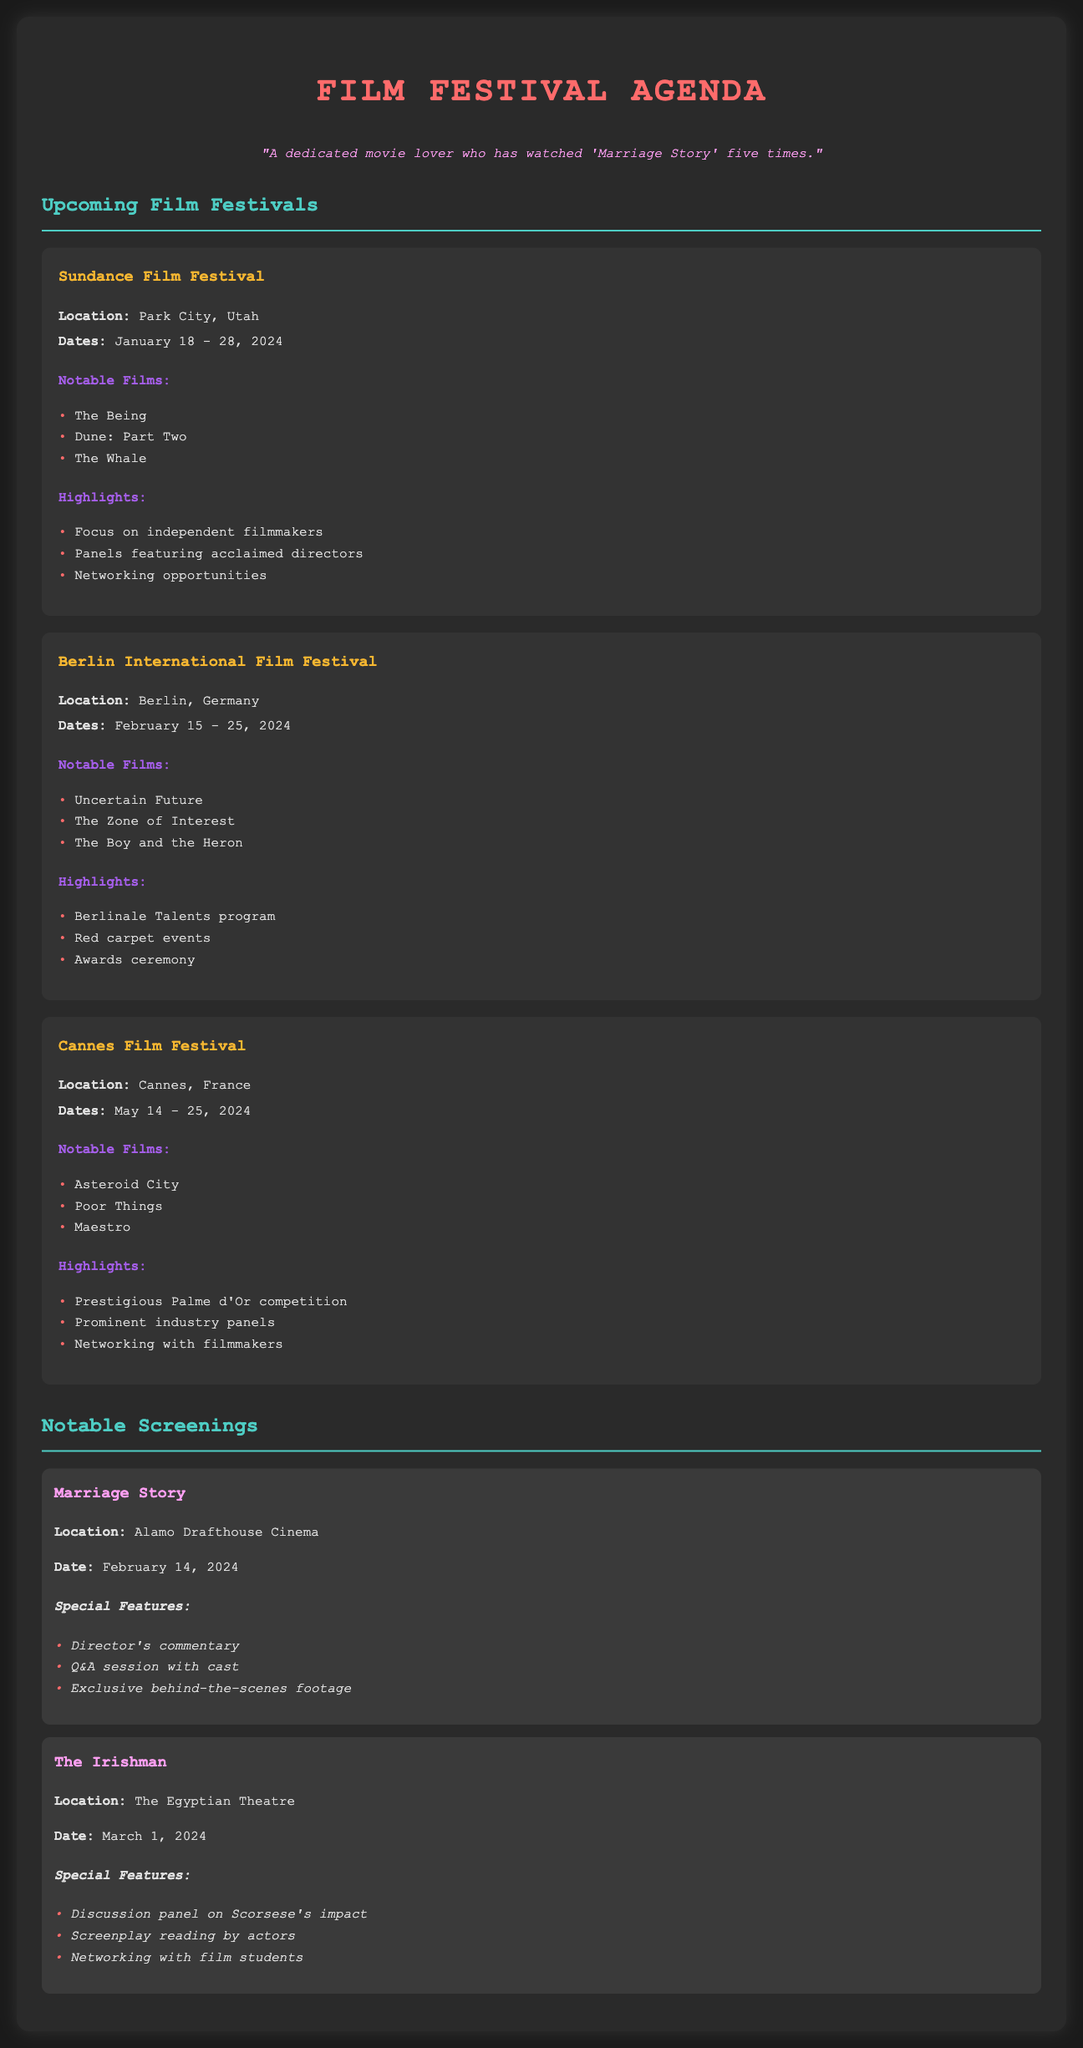What are the dates of the Sundance Film Festival? The dates of the Sundance Film Festival are mentioned in the document as January 18 - 28, 2024.
Answer: January 18 - 28, 2024 Where is the Berlin International Film Festival located? The location of the Berlin International Film Festival is stated in the document as Berlin, Germany.
Answer: Berlin, Germany What is one notable film being screened at the Cannes Film Festival? The document lists notable films at the Cannes Film Festival, one of which is Asteroid City.
Answer: Asteroid City Which film has a screening date of February 14, 2024? The document specifies that Marriage Story has a screening date of February 14, 2024.
Answer: Marriage Story What special feature is included in the screening of The Irishman? The document mentions several special features, one of which is a discussion panel on Scorsese's impact for The Irishman.
Answer: Discussion panel on Scorsese's impact How many days does the Cannes Film Festival last? The document states the Cannes Film Festival runs from May 14 to May 25, 2024, which is 12 days.
Answer: 12 days Which festival highlights focus on independent filmmakers? The document states that the Sundance Film Festival highlights include a focus on independent filmmakers.
Answer: Sundance Film Festival What is one feature of the notable screening of Marriage Story? The document lists the director's commentary as one of the special features for the Marriage Story screening.
Answer: Director's commentary 